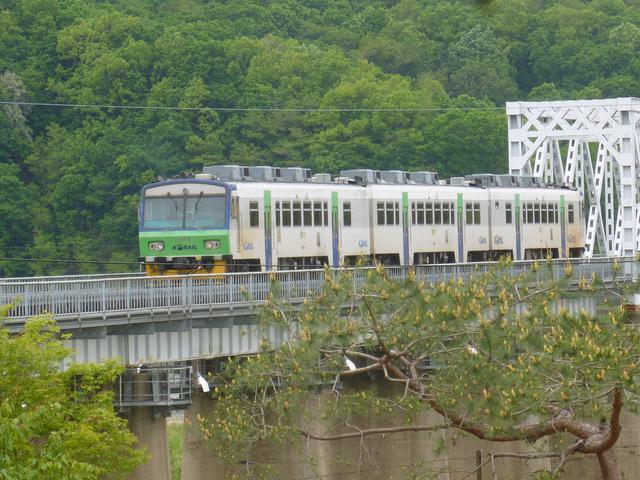How many cars are there?
Give a very brief answer. 3. How many blue frosted donuts can you count?
Give a very brief answer. 0. 